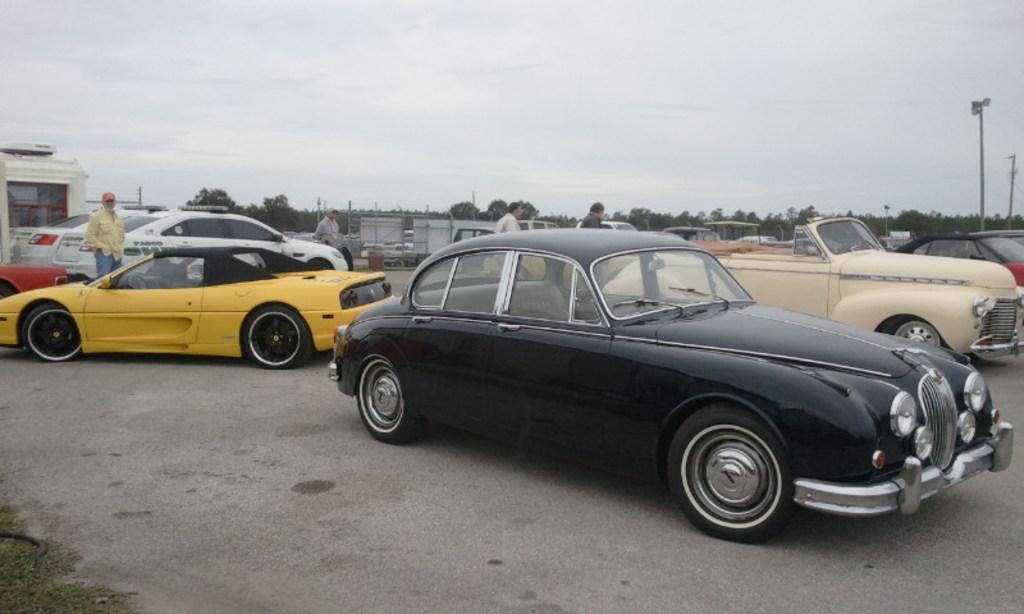In one or two sentences, can you explain what this image depicts? In this picture there are cars and people in the center of the image and there are trees and poles in the background area of the image. 